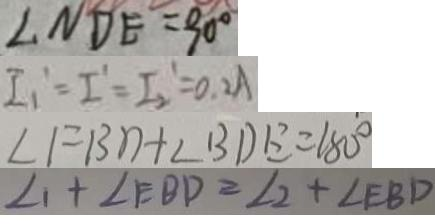Convert formula to latex. <formula><loc_0><loc_0><loc_500><loc_500>\angle N D E = 9 0 ^ { \circ } 
 I _ { 1 } ^ { \prime } = I ^ { \prime } = I _ { 2 } ^ { 1 } = 0 . 2 A 
 \angle F B D + \angle B D E = 1 8 0 ^ { \circ } 
 \angle 1 + \angle E B D = \angle 2 + \angle E B D</formula> 